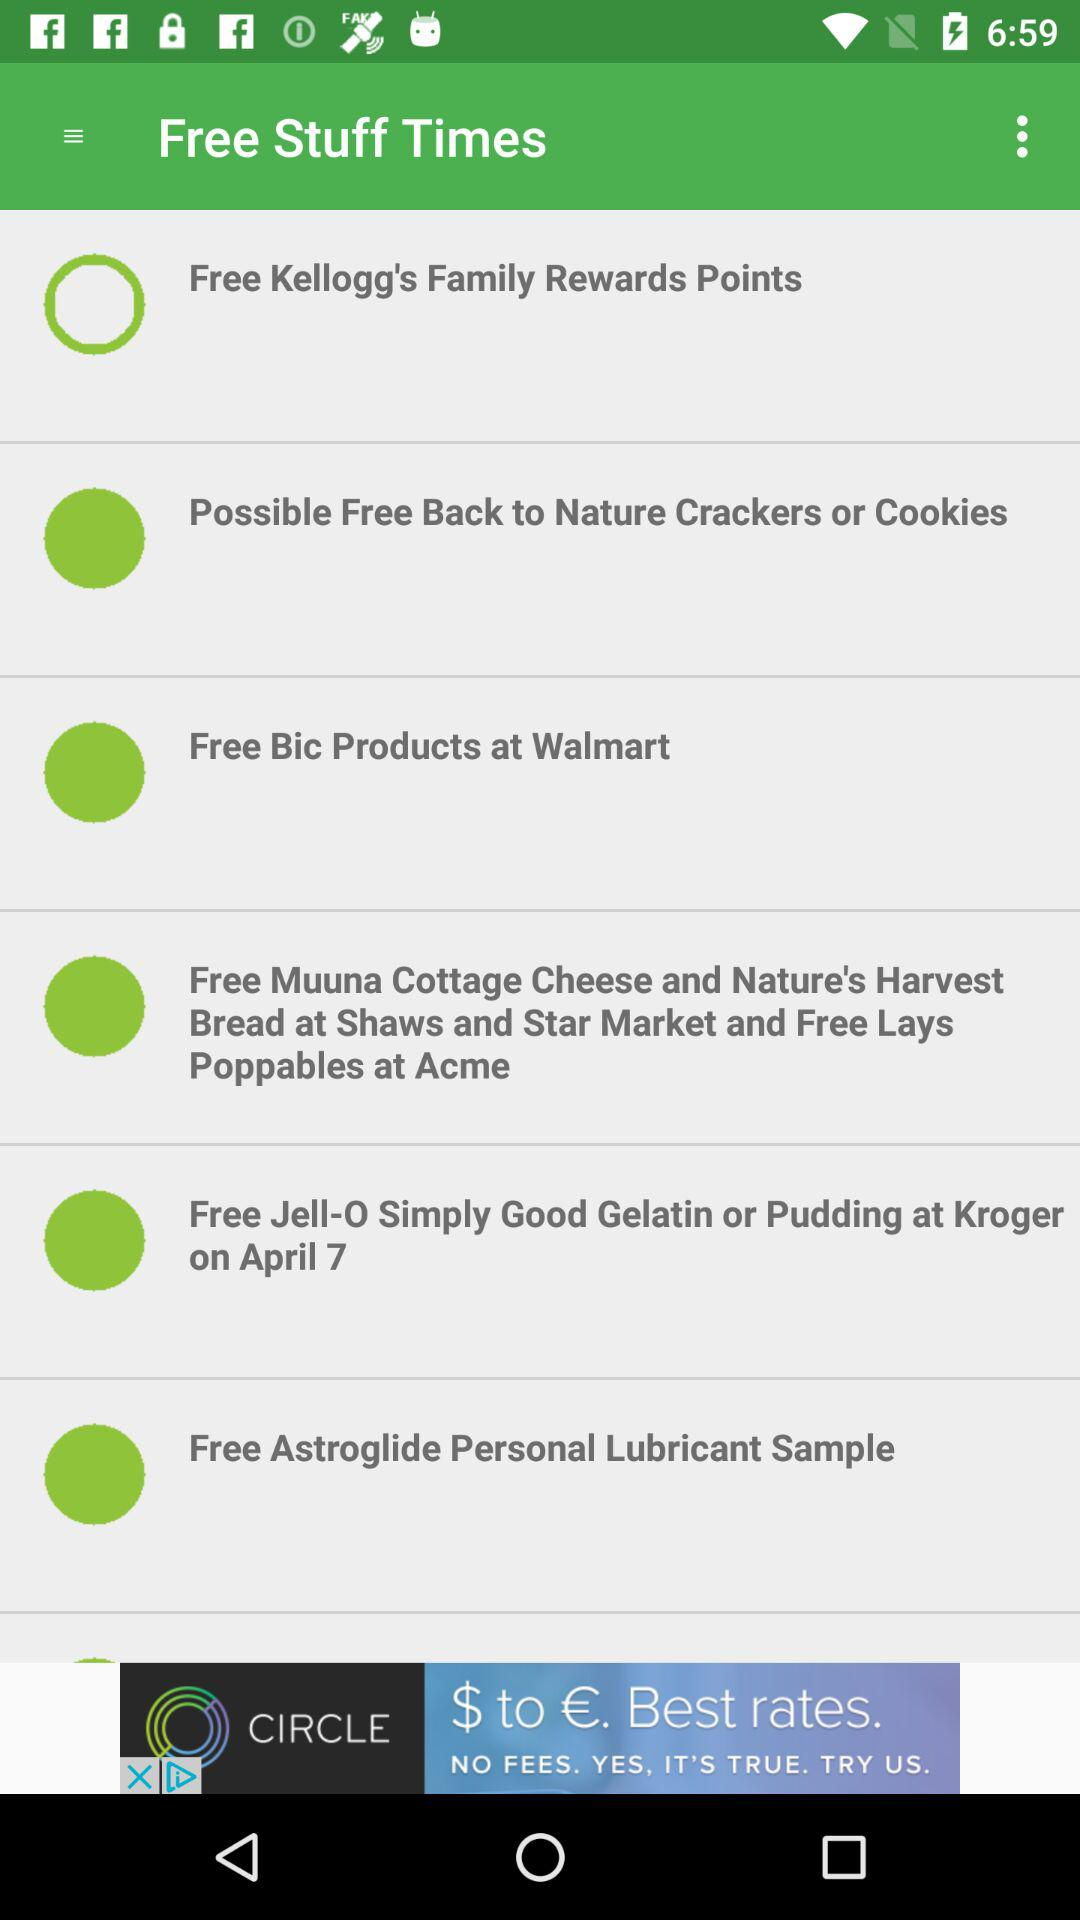How many Kellogg's Family Rewards Points are there?
When the provided information is insufficient, respond with <no answer>. <no answer> 